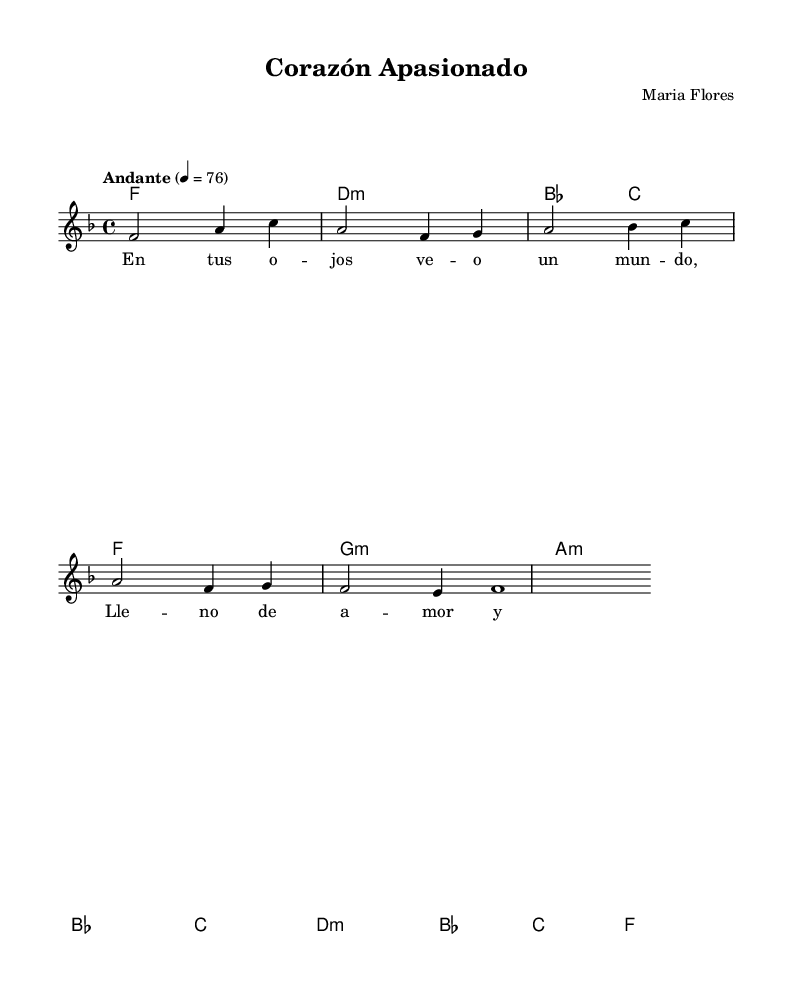What is the key signature of this music? The key signature is F major, which is indicated by one flat (B flat). This can be identified at the beginning of the score where the key signature is shown.
Answer: F major What is the time signature of this piece? The time signature is 4/4, shown at the beginning of the score. This means there are four beats in each measure and the quarter note receives one beat.
Answer: 4/4 What is the tempo marking of the music? The tempo marking is "Andante" which indicates a moderately slow tempo, typically around 76 beats per minute. This is found directly above the staff.
Answer: Andante How many measures are in the melody section? The melody section consists of eight measures, which can be counted by the vertical bar lines that separate the measures in the score.
Answer: Eight What is the first lyric of the song? The first lyric of the song is "En tus ojos veo un mundo," which is provided in the lyric mode and corresponds to the first section of the melody.
Answer: En tus ojos veo un mundo How many chords are used in the harmonies? There are eight unique chords used in the harmonies section, which are indicated by the chord symbols placed above the standard notation.
Answer: Eight What mood does the title "Corazón Apasionado" suggest for the song? The title "Corazón Apasionado" translates to "Passionate Heart," suggesting a romantic and emotional mood, which is typical for many Latin pop ballads featured in telenovelas.
Answer: Passionate 